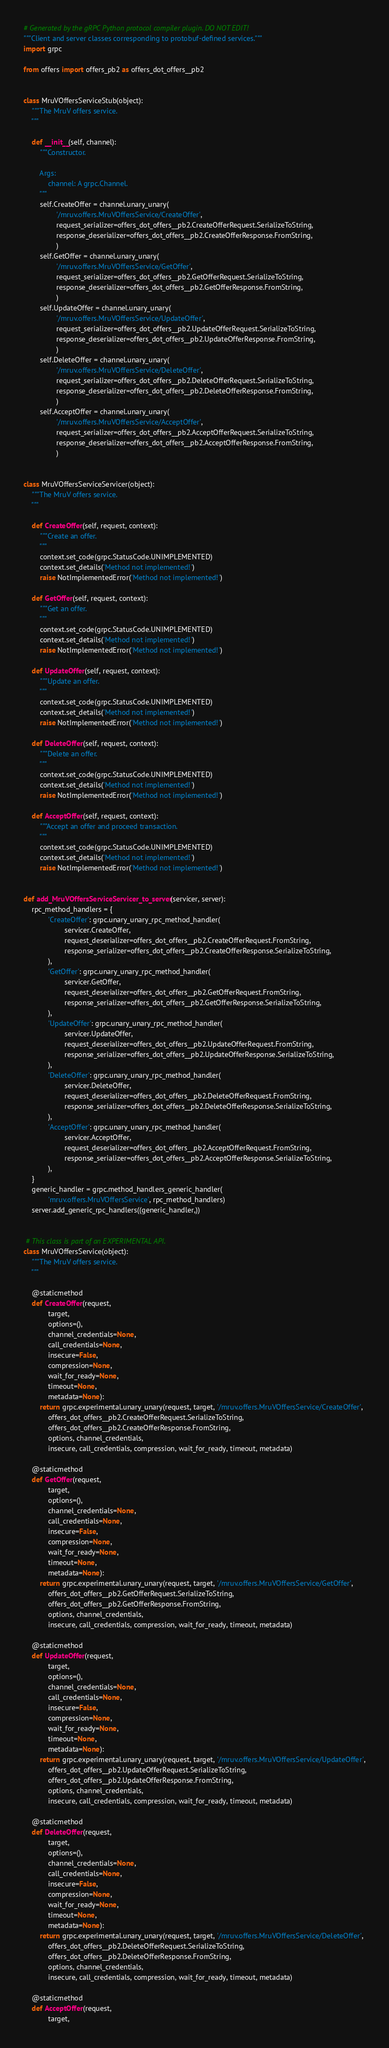<code> <loc_0><loc_0><loc_500><loc_500><_Python_># Generated by the gRPC Python protocol compiler plugin. DO NOT EDIT!
"""Client and server classes corresponding to protobuf-defined services."""
import grpc

from offers import offers_pb2 as offers_dot_offers__pb2


class MruVOffersServiceStub(object):
    """The MruV offers service.
    """

    def __init__(self, channel):
        """Constructor.

        Args:
            channel: A grpc.Channel.
        """
        self.CreateOffer = channel.unary_unary(
                '/mruv.offers.MruVOffersService/CreateOffer',
                request_serializer=offers_dot_offers__pb2.CreateOfferRequest.SerializeToString,
                response_deserializer=offers_dot_offers__pb2.CreateOfferResponse.FromString,
                )
        self.GetOffer = channel.unary_unary(
                '/mruv.offers.MruVOffersService/GetOffer',
                request_serializer=offers_dot_offers__pb2.GetOfferRequest.SerializeToString,
                response_deserializer=offers_dot_offers__pb2.GetOfferResponse.FromString,
                )
        self.UpdateOffer = channel.unary_unary(
                '/mruv.offers.MruVOffersService/UpdateOffer',
                request_serializer=offers_dot_offers__pb2.UpdateOfferRequest.SerializeToString,
                response_deserializer=offers_dot_offers__pb2.UpdateOfferResponse.FromString,
                )
        self.DeleteOffer = channel.unary_unary(
                '/mruv.offers.MruVOffersService/DeleteOffer',
                request_serializer=offers_dot_offers__pb2.DeleteOfferRequest.SerializeToString,
                response_deserializer=offers_dot_offers__pb2.DeleteOfferResponse.FromString,
                )
        self.AcceptOffer = channel.unary_unary(
                '/mruv.offers.MruVOffersService/AcceptOffer',
                request_serializer=offers_dot_offers__pb2.AcceptOfferRequest.SerializeToString,
                response_deserializer=offers_dot_offers__pb2.AcceptOfferResponse.FromString,
                )


class MruVOffersServiceServicer(object):
    """The MruV offers service.
    """

    def CreateOffer(self, request, context):
        """Create an offer.
        """
        context.set_code(grpc.StatusCode.UNIMPLEMENTED)
        context.set_details('Method not implemented!')
        raise NotImplementedError('Method not implemented!')

    def GetOffer(self, request, context):
        """Get an offer.
        """
        context.set_code(grpc.StatusCode.UNIMPLEMENTED)
        context.set_details('Method not implemented!')
        raise NotImplementedError('Method not implemented!')

    def UpdateOffer(self, request, context):
        """Update an offer.
        """
        context.set_code(grpc.StatusCode.UNIMPLEMENTED)
        context.set_details('Method not implemented!')
        raise NotImplementedError('Method not implemented!')

    def DeleteOffer(self, request, context):
        """Delete an offer.
        """
        context.set_code(grpc.StatusCode.UNIMPLEMENTED)
        context.set_details('Method not implemented!')
        raise NotImplementedError('Method not implemented!')

    def AcceptOffer(self, request, context):
        """Accept an offer and proceed transaction.
        """
        context.set_code(grpc.StatusCode.UNIMPLEMENTED)
        context.set_details('Method not implemented!')
        raise NotImplementedError('Method not implemented!')


def add_MruVOffersServiceServicer_to_server(servicer, server):
    rpc_method_handlers = {
            'CreateOffer': grpc.unary_unary_rpc_method_handler(
                    servicer.CreateOffer,
                    request_deserializer=offers_dot_offers__pb2.CreateOfferRequest.FromString,
                    response_serializer=offers_dot_offers__pb2.CreateOfferResponse.SerializeToString,
            ),
            'GetOffer': grpc.unary_unary_rpc_method_handler(
                    servicer.GetOffer,
                    request_deserializer=offers_dot_offers__pb2.GetOfferRequest.FromString,
                    response_serializer=offers_dot_offers__pb2.GetOfferResponse.SerializeToString,
            ),
            'UpdateOffer': grpc.unary_unary_rpc_method_handler(
                    servicer.UpdateOffer,
                    request_deserializer=offers_dot_offers__pb2.UpdateOfferRequest.FromString,
                    response_serializer=offers_dot_offers__pb2.UpdateOfferResponse.SerializeToString,
            ),
            'DeleteOffer': grpc.unary_unary_rpc_method_handler(
                    servicer.DeleteOffer,
                    request_deserializer=offers_dot_offers__pb2.DeleteOfferRequest.FromString,
                    response_serializer=offers_dot_offers__pb2.DeleteOfferResponse.SerializeToString,
            ),
            'AcceptOffer': grpc.unary_unary_rpc_method_handler(
                    servicer.AcceptOffer,
                    request_deserializer=offers_dot_offers__pb2.AcceptOfferRequest.FromString,
                    response_serializer=offers_dot_offers__pb2.AcceptOfferResponse.SerializeToString,
            ),
    }
    generic_handler = grpc.method_handlers_generic_handler(
            'mruv.offers.MruVOffersService', rpc_method_handlers)
    server.add_generic_rpc_handlers((generic_handler,))


 # This class is part of an EXPERIMENTAL API.
class MruVOffersService(object):
    """The MruV offers service.
    """

    @staticmethod
    def CreateOffer(request,
            target,
            options=(),
            channel_credentials=None,
            call_credentials=None,
            insecure=False,
            compression=None,
            wait_for_ready=None,
            timeout=None,
            metadata=None):
        return grpc.experimental.unary_unary(request, target, '/mruv.offers.MruVOffersService/CreateOffer',
            offers_dot_offers__pb2.CreateOfferRequest.SerializeToString,
            offers_dot_offers__pb2.CreateOfferResponse.FromString,
            options, channel_credentials,
            insecure, call_credentials, compression, wait_for_ready, timeout, metadata)

    @staticmethod
    def GetOffer(request,
            target,
            options=(),
            channel_credentials=None,
            call_credentials=None,
            insecure=False,
            compression=None,
            wait_for_ready=None,
            timeout=None,
            metadata=None):
        return grpc.experimental.unary_unary(request, target, '/mruv.offers.MruVOffersService/GetOffer',
            offers_dot_offers__pb2.GetOfferRequest.SerializeToString,
            offers_dot_offers__pb2.GetOfferResponse.FromString,
            options, channel_credentials,
            insecure, call_credentials, compression, wait_for_ready, timeout, metadata)

    @staticmethod
    def UpdateOffer(request,
            target,
            options=(),
            channel_credentials=None,
            call_credentials=None,
            insecure=False,
            compression=None,
            wait_for_ready=None,
            timeout=None,
            metadata=None):
        return grpc.experimental.unary_unary(request, target, '/mruv.offers.MruVOffersService/UpdateOffer',
            offers_dot_offers__pb2.UpdateOfferRequest.SerializeToString,
            offers_dot_offers__pb2.UpdateOfferResponse.FromString,
            options, channel_credentials,
            insecure, call_credentials, compression, wait_for_ready, timeout, metadata)

    @staticmethod
    def DeleteOffer(request,
            target,
            options=(),
            channel_credentials=None,
            call_credentials=None,
            insecure=False,
            compression=None,
            wait_for_ready=None,
            timeout=None,
            metadata=None):
        return grpc.experimental.unary_unary(request, target, '/mruv.offers.MruVOffersService/DeleteOffer',
            offers_dot_offers__pb2.DeleteOfferRequest.SerializeToString,
            offers_dot_offers__pb2.DeleteOfferResponse.FromString,
            options, channel_credentials,
            insecure, call_credentials, compression, wait_for_ready, timeout, metadata)

    @staticmethod
    def AcceptOffer(request,
            target,</code> 